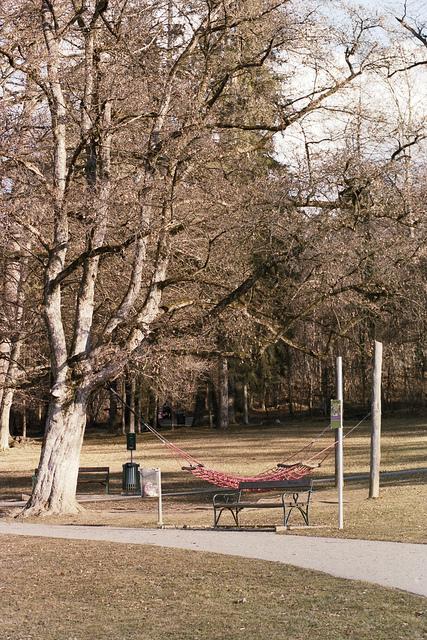Where is the hammock located?
Answer briefly. In park. What color is the sidewalk?
Write a very short answer. Gray. How many benches are there?
Short answer required. 2. 